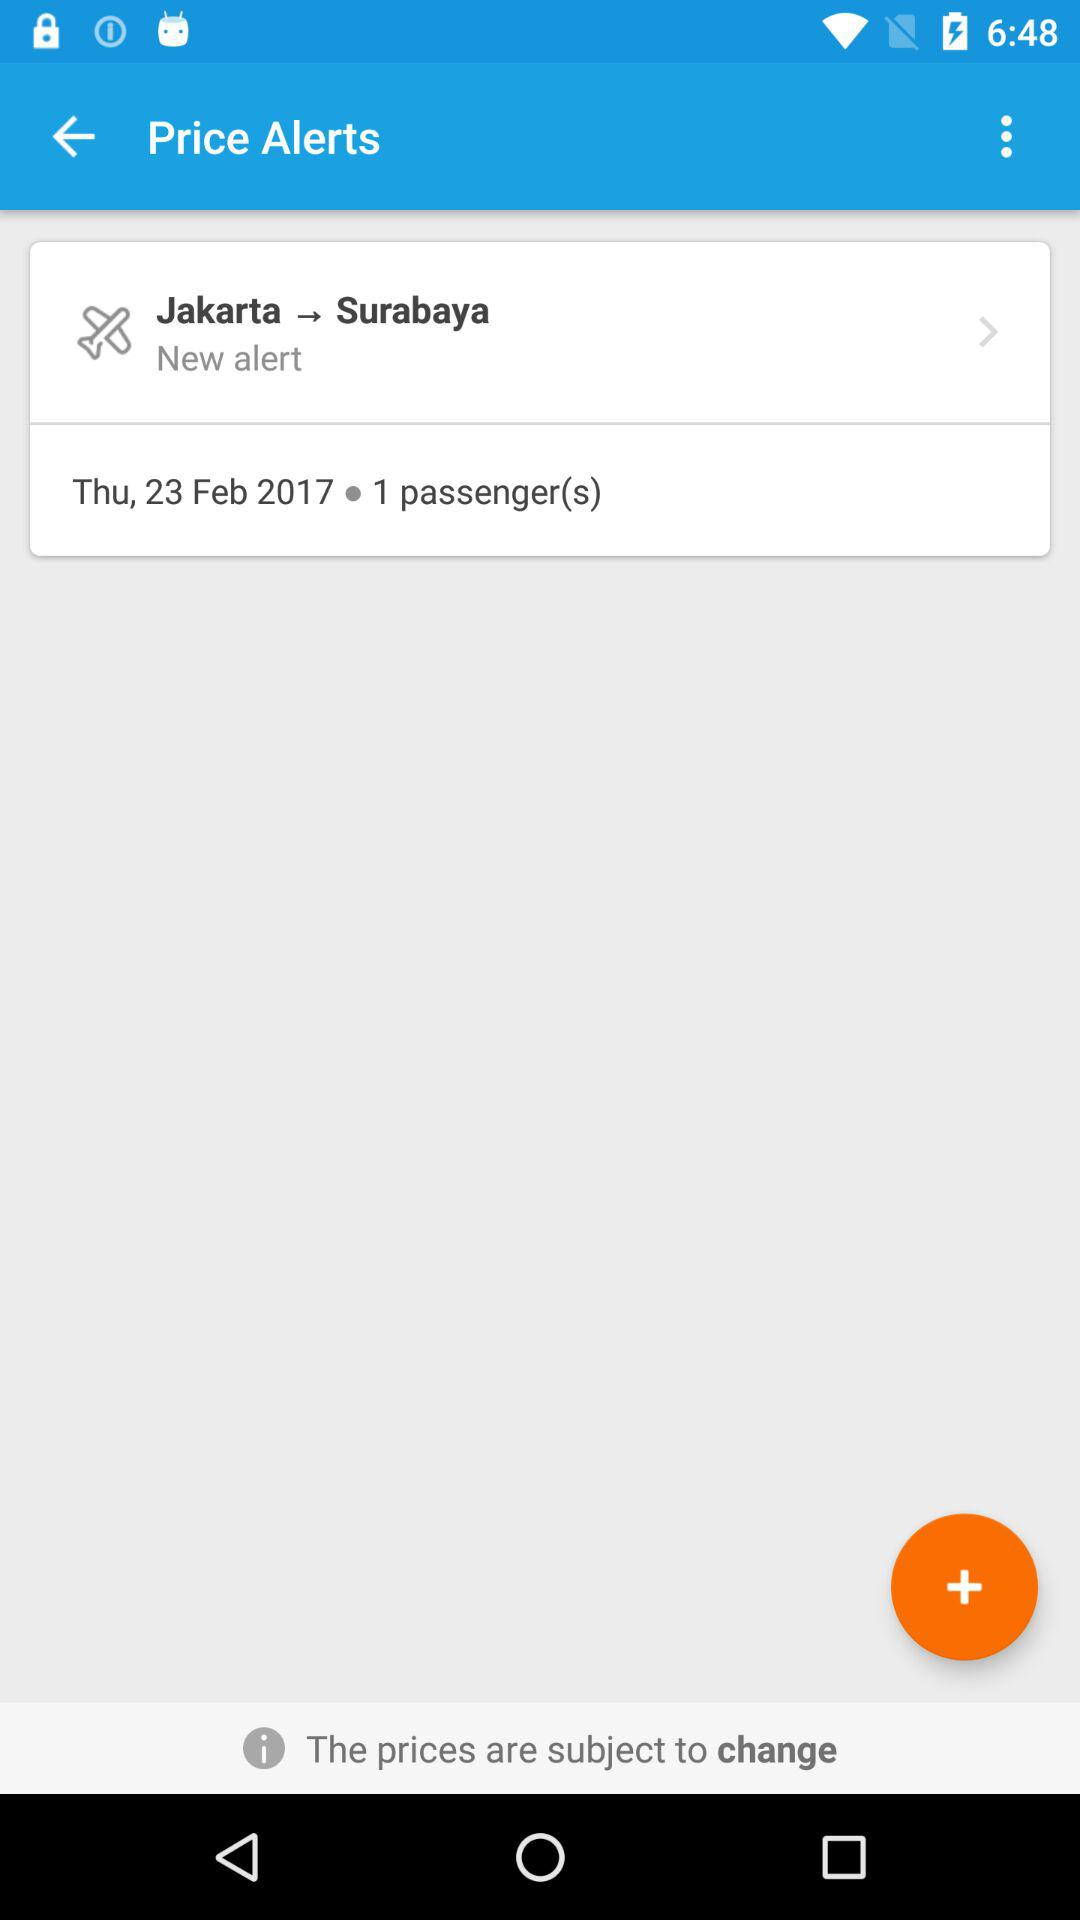How many passengers are there in the alert?
Answer the question using a single word or phrase. 1 